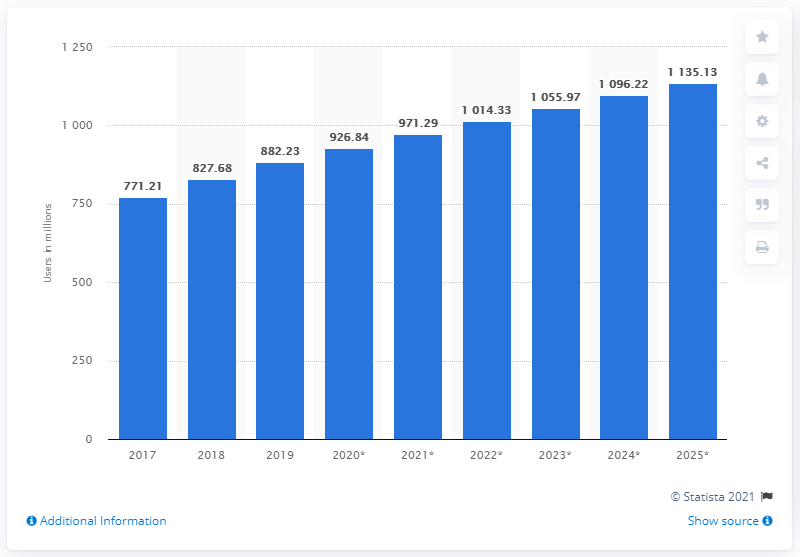Draw attention to some important aspects in this diagram. How many users have Tencent WeChat and Weibo attracted in China? As of December 2021, there are a staggering 882.23 million users using these two popular social media platforms in China. There were approximately 882.23 million social media users in China in 2019. 